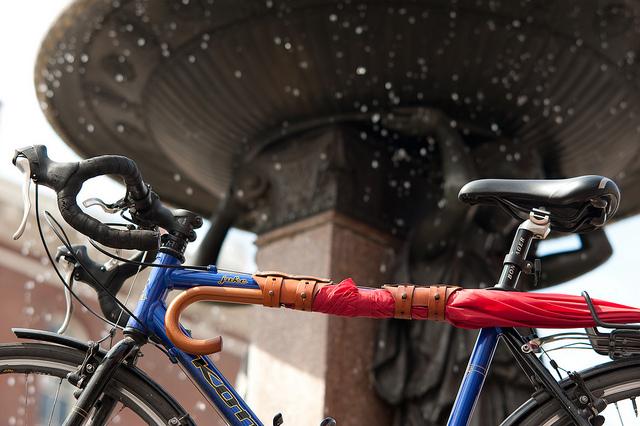What kind of bike is this?
Concise answer only. Road bike. Is someone on the bike?
Short answer required. No. What is attached to the bicycle?
Concise answer only. Umbrella. 